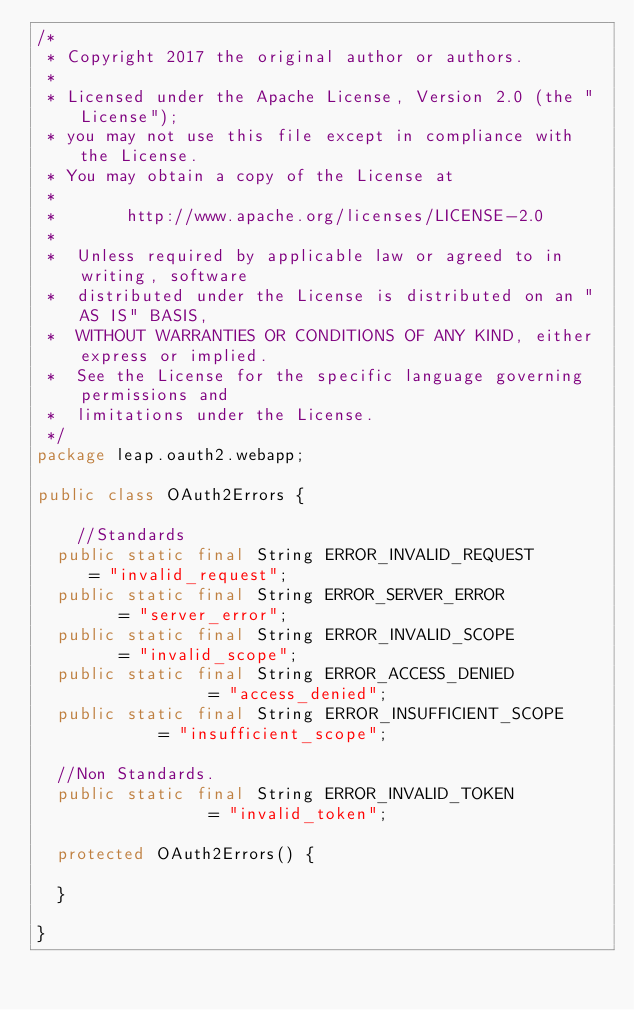Convert code to text. <code><loc_0><loc_0><loc_500><loc_500><_Java_>/*
 * Copyright 2017 the original author or authors.
 *
 * Licensed under the Apache License, Version 2.0 (the "License");
 * you may not use this file except in compliance with the License.
 * You may obtain a copy of the License at
 *
 *       http://www.apache.org/licenses/LICENSE-2.0
 *
 *  Unless required by applicable law or agreed to in writing, software
 *  distributed under the License is distributed on an "AS IS" BASIS,
 *  WITHOUT WARRANTIES OR CONDITIONS OF ANY KIND, either express or implied.
 *  See the License for the specific language governing permissions and
 *  limitations under the License.
 */
package leap.oauth2.webapp;

public class OAuth2Errors {

    //Standards
	public static final String ERROR_INVALID_REQUEST 		   = "invalid_request";
	public static final String ERROR_SERVER_ERROR    	   	   = "server_error";
	public static final String ERROR_INVALID_SCOPE    		   = "invalid_scope";
	public static final String ERROR_ACCESS_DENIED             = "access_denied";
	public static final String ERROR_INSUFFICIENT_SCOPE        = "insufficient_scope";

	//Non Standards.
	public static final String ERROR_INVALID_TOKEN             = "invalid_token";

	protected OAuth2Errors() {

	}

}
</code> 